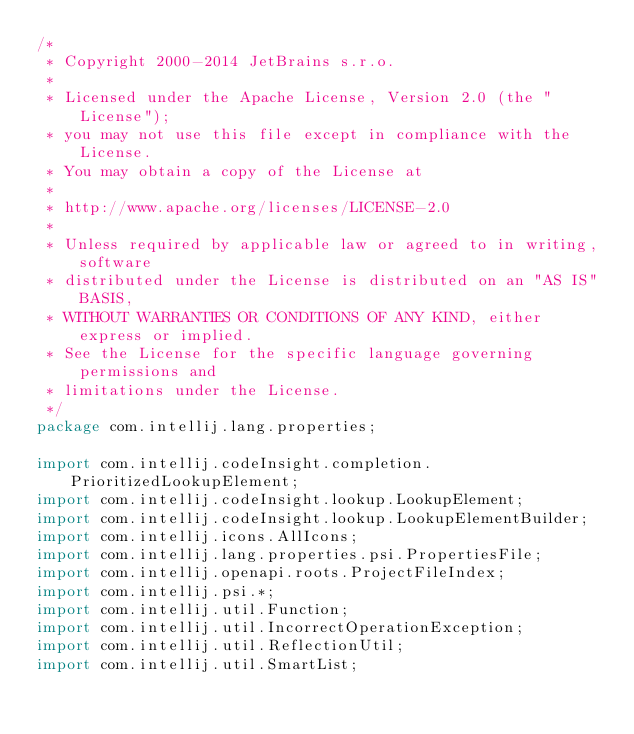<code> <loc_0><loc_0><loc_500><loc_500><_Java_>/*
 * Copyright 2000-2014 JetBrains s.r.o.
 *
 * Licensed under the Apache License, Version 2.0 (the "License");
 * you may not use this file except in compliance with the License.
 * You may obtain a copy of the License at
 *
 * http://www.apache.org/licenses/LICENSE-2.0
 *
 * Unless required by applicable law or agreed to in writing, software
 * distributed under the License is distributed on an "AS IS" BASIS,
 * WITHOUT WARRANTIES OR CONDITIONS OF ANY KIND, either express or implied.
 * See the License for the specific language governing permissions and
 * limitations under the License.
 */
package com.intellij.lang.properties;

import com.intellij.codeInsight.completion.PrioritizedLookupElement;
import com.intellij.codeInsight.lookup.LookupElement;
import com.intellij.codeInsight.lookup.LookupElementBuilder;
import com.intellij.icons.AllIcons;
import com.intellij.lang.properties.psi.PropertiesFile;
import com.intellij.openapi.roots.ProjectFileIndex;
import com.intellij.psi.*;
import com.intellij.util.Function;
import com.intellij.util.IncorrectOperationException;
import com.intellij.util.ReflectionUtil;
import com.intellij.util.SmartList;</code> 